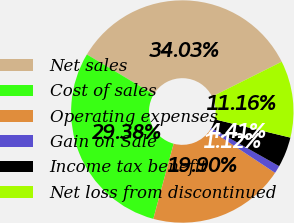Convert chart. <chart><loc_0><loc_0><loc_500><loc_500><pie_chart><fcel>Net sales<fcel>Cost of sales<fcel>Operating expenses<fcel>Gain on Sale<fcel>Income tax benefit<fcel>Net loss from discontinued<nl><fcel>34.03%<fcel>29.38%<fcel>19.9%<fcel>1.12%<fcel>4.41%<fcel>11.16%<nl></chart> 